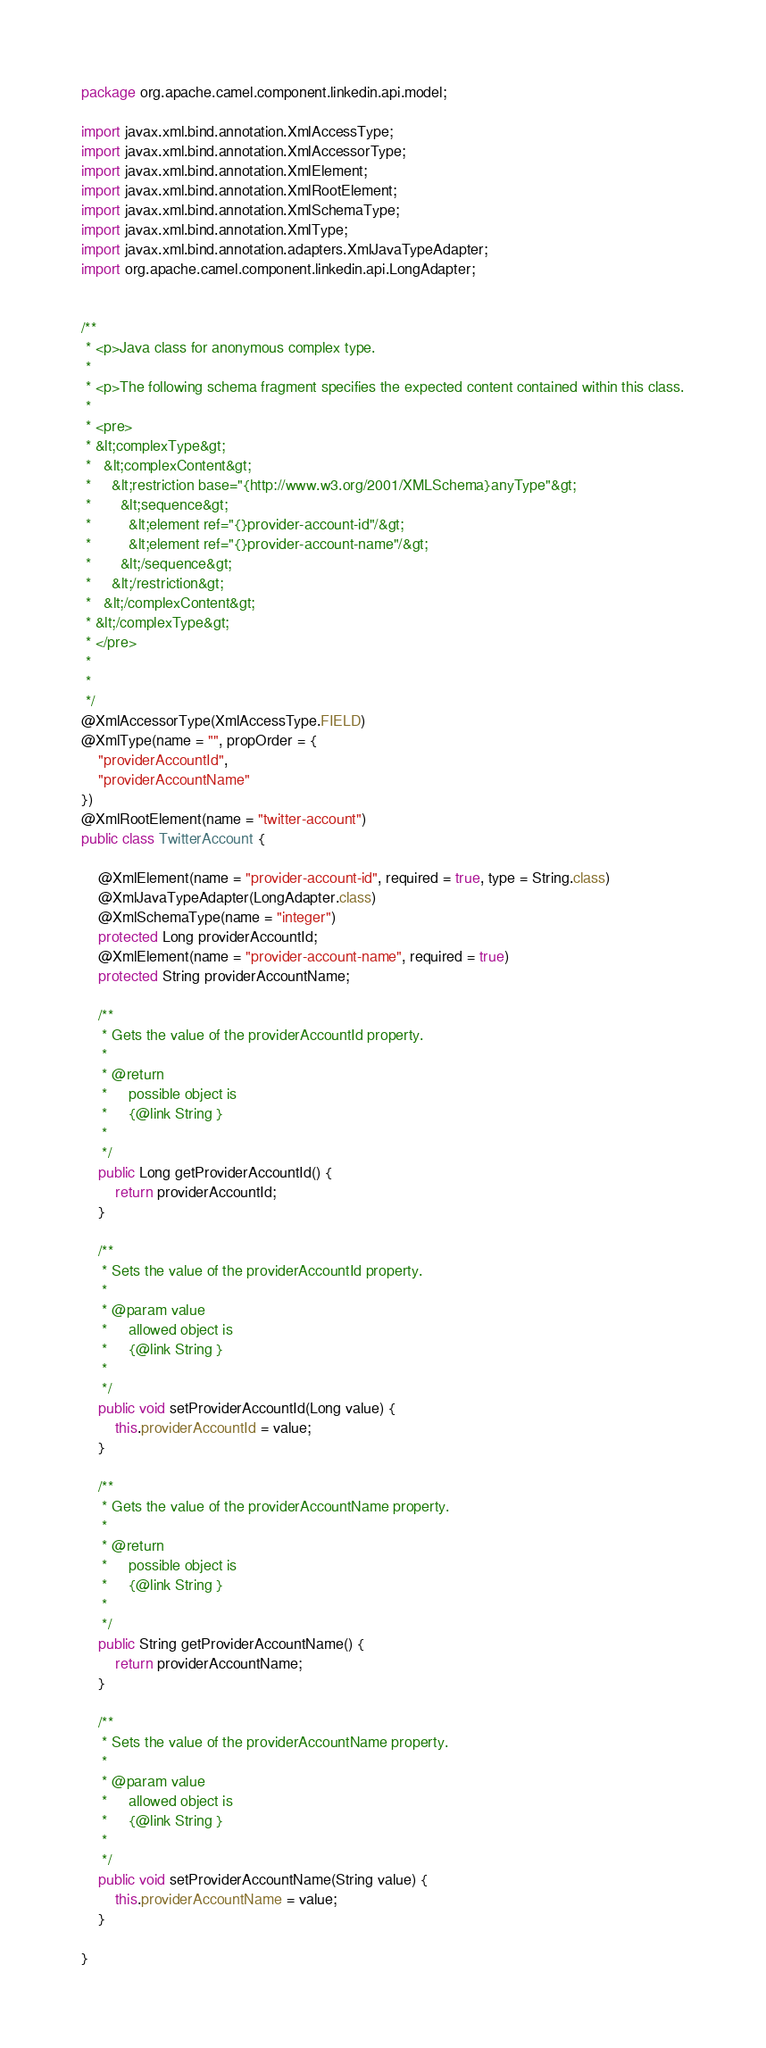Convert code to text. <code><loc_0><loc_0><loc_500><loc_500><_Java_>
package org.apache.camel.component.linkedin.api.model;

import javax.xml.bind.annotation.XmlAccessType;
import javax.xml.bind.annotation.XmlAccessorType;
import javax.xml.bind.annotation.XmlElement;
import javax.xml.bind.annotation.XmlRootElement;
import javax.xml.bind.annotation.XmlSchemaType;
import javax.xml.bind.annotation.XmlType;
import javax.xml.bind.annotation.adapters.XmlJavaTypeAdapter;
import org.apache.camel.component.linkedin.api.LongAdapter;


/**
 * <p>Java class for anonymous complex type.
 * 
 * <p>The following schema fragment specifies the expected content contained within this class.
 * 
 * <pre>
 * &lt;complexType&gt;
 *   &lt;complexContent&gt;
 *     &lt;restriction base="{http://www.w3.org/2001/XMLSchema}anyType"&gt;
 *       &lt;sequence&gt;
 *         &lt;element ref="{}provider-account-id"/&gt;
 *         &lt;element ref="{}provider-account-name"/&gt;
 *       &lt;/sequence&gt;
 *     &lt;/restriction&gt;
 *   &lt;/complexContent&gt;
 * &lt;/complexType&gt;
 * </pre>
 * 
 * 
 */
@XmlAccessorType(XmlAccessType.FIELD)
@XmlType(name = "", propOrder = {
    "providerAccountId",
    "providerAccountName"
})
@XmlRootElement(name = "twitter-account")
public class TwitterAccount {

    @XmlElement(name = "provider-account-id", required = true, type = String.class)
    @XmlJavaTypeAdapter(LongAdapter.class)
    @XmlSchemaType(name = "integer")
    protected Long providerAccountId;
    @XmlElement(name = "provider-account-name", required = true)
    protected String providerAccountName;

    /**
     * Gets the value of the providerAccountId property.
     * 
     * @return
     *     possible object is
     *     {@link String }
     *     
     */
    public Long getProviderAccountId() {
        return providerAccountId;
    }

    /**
     * Sets the value of the providerAccountId property.
     * 
     * @param value
     *     allowed object is
     *     {@link String }
     *     
     */
    public void setProviderAccountId(Long value) {
        this.providerAccountId = value;
    }

    /**
     * Gets the value of the providerAccountName property.
     * 
     * @return
     *     possible object is
     *     {@link String }
     *     
     */
    public String getProviderAccountName() {
        return providerAccountName;
    }

    /**
     * Sets the value of the providerAccountName property.
     * 
     * @param value
     *     allowed object is
     *     {@link String }
     *     
     */
    public void setProviderAccountName(String value) {
        this.providerAccountName = value;
    }

}
</code> 